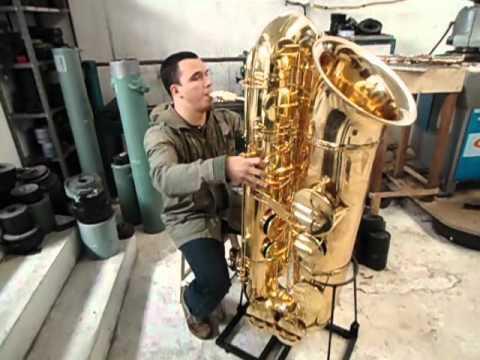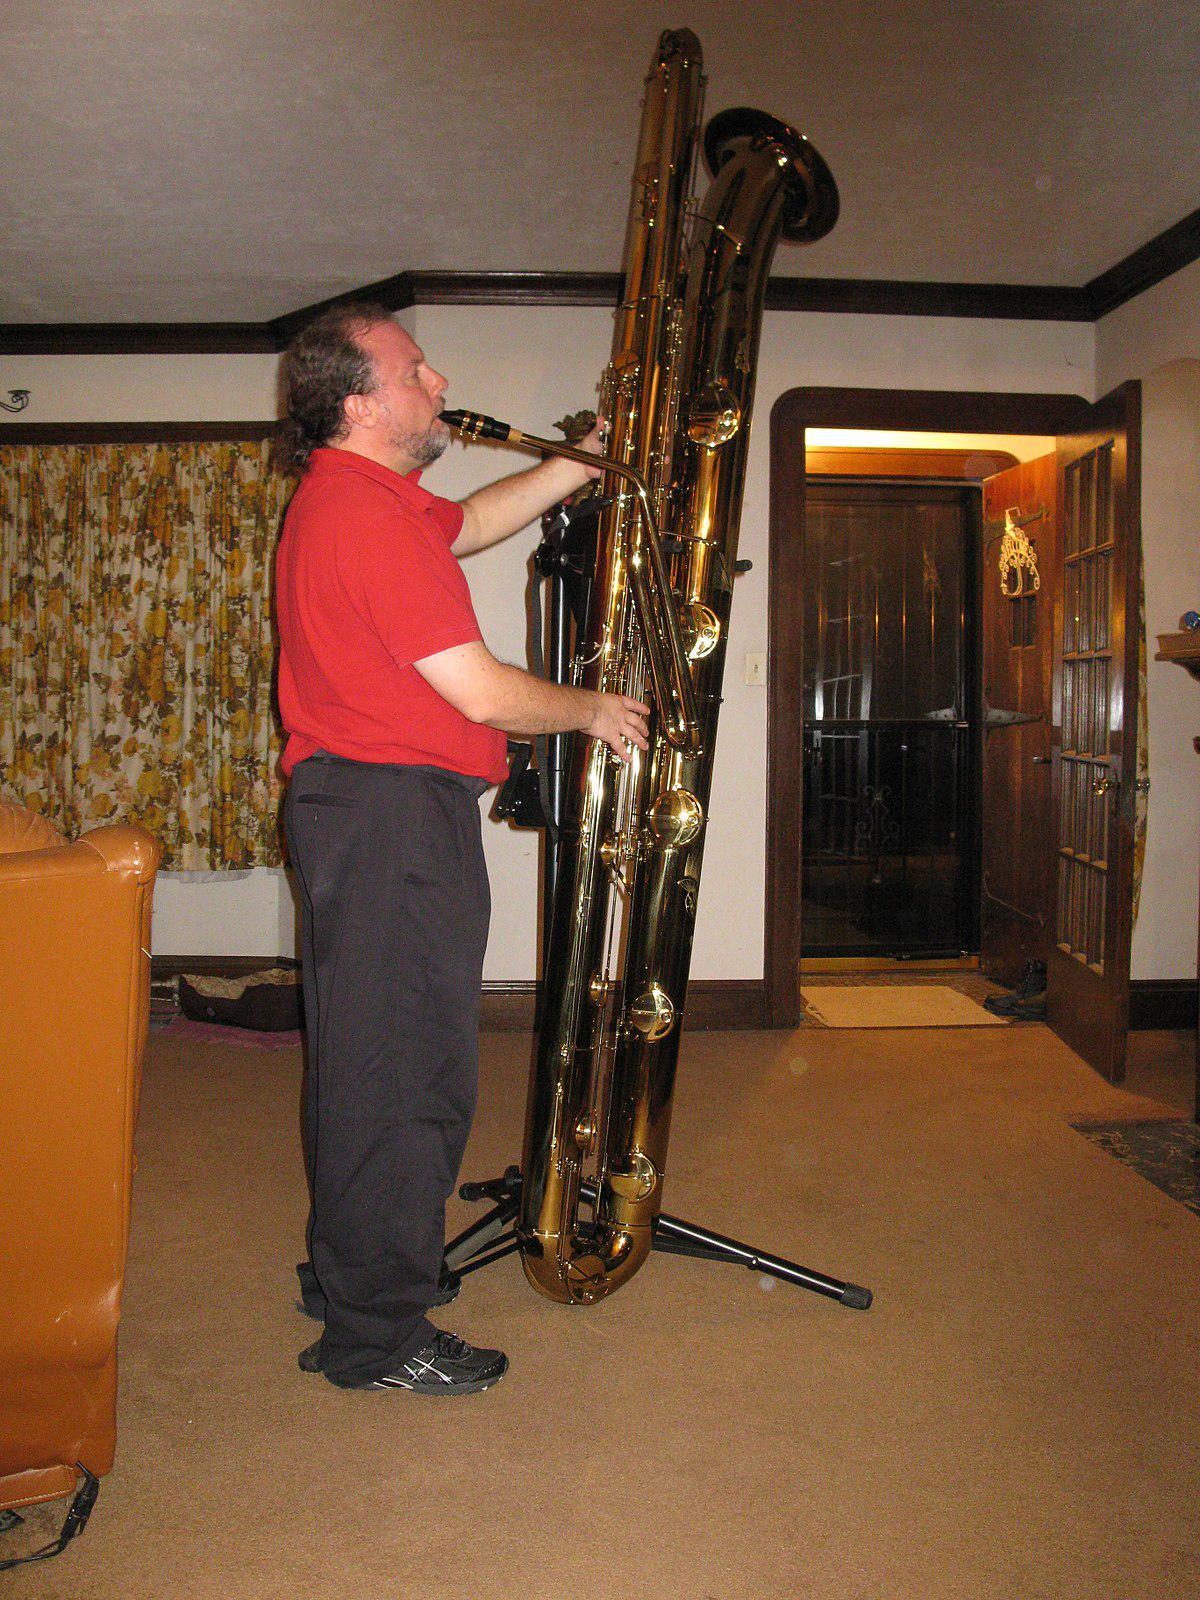The first image is the image on the left, the second image is the image on the right. Assess this claim about the two images: "Each image shows a man with an oversized gold saxophone, and in at least one image, the saxophone is on a black stand.". Correct or not? Answer yes or no. Yes. The first image is the image on the left, the second image is the image on the right. For the images displayed, is the sentence "In at least one  image there is a young man with a supersized saxophone tilted right and strapped to him while he is playing it." factually correct? Answer yes or no. No. 